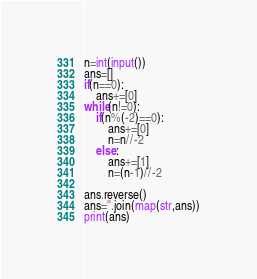Convert code to text. <code><loc_0><loc_0><loc_500><loc_500><_Python_>n=int(input())
ans=[]
if(n==0):
    ans+=[0]
while(n!=0):
    if(n%(-2)==0):
        ans+=[0]
        n=n//-2
    else:
        ans+=[1]
        n=(n-1)//-2

ans.reverse()
ans=''.join(map(str,ans))
print(ans)</code> 